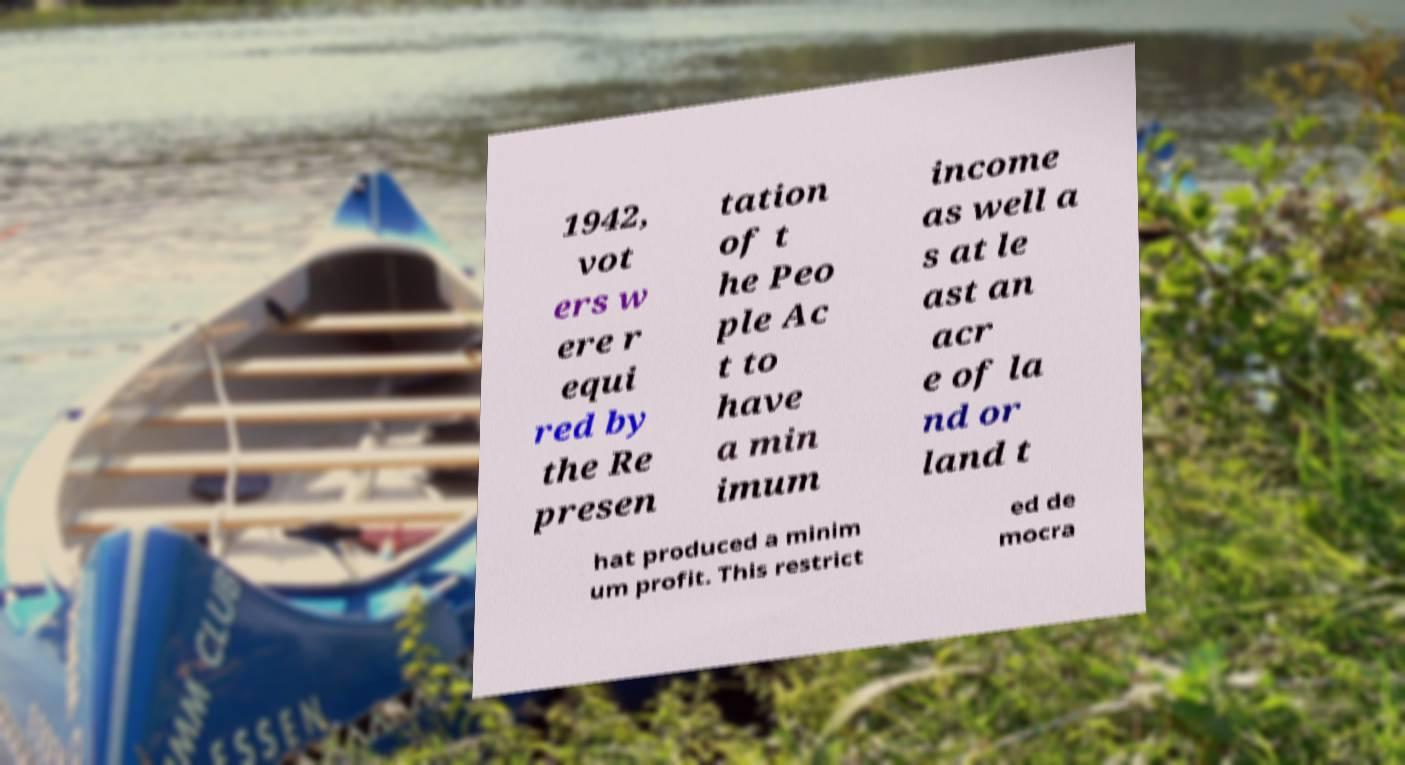There's text embedded in this image that I need extracted. Can you transcribe it verbatim? 1942, vot ers w ere r equi red by the Re presen tation of t he Peo ple Ac t to have a min imum income as well a s at le ast an acr e of la nd or land t hat produced a minim um profit. This restrict ed de mocra 